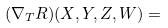Convert formula to latex. <formula><loc_0><loc_0><loc_500><loc_500>( \nabla _ { T } R ) ( X , Y , Z , W ) =</formula> 